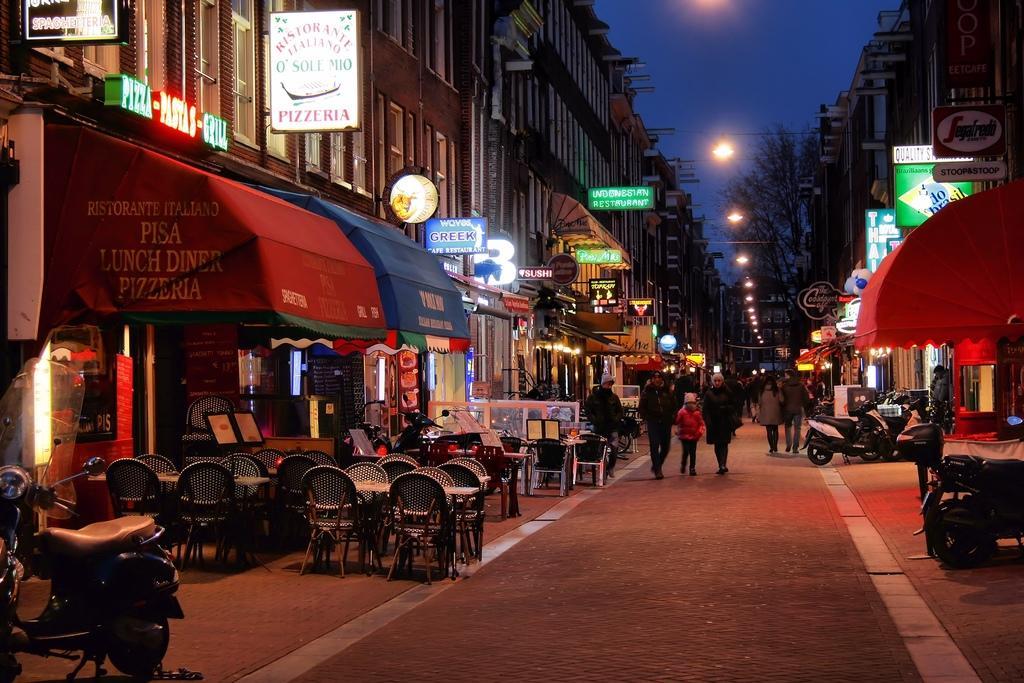In one or two sentences, can you explain what this image depicts? It is a street and the image is captured in the night time, there are a lot of stores beside the road and in front of one of the stores there are a lot of chairs and in between the chairs there are two tables and there are some vehicles parked in front of those stores, they are beautiful light and up and there are a lot of street lights that are attached to the buildings above the stores, many people are walking on the road in front of stores. In the background there are some trees. 